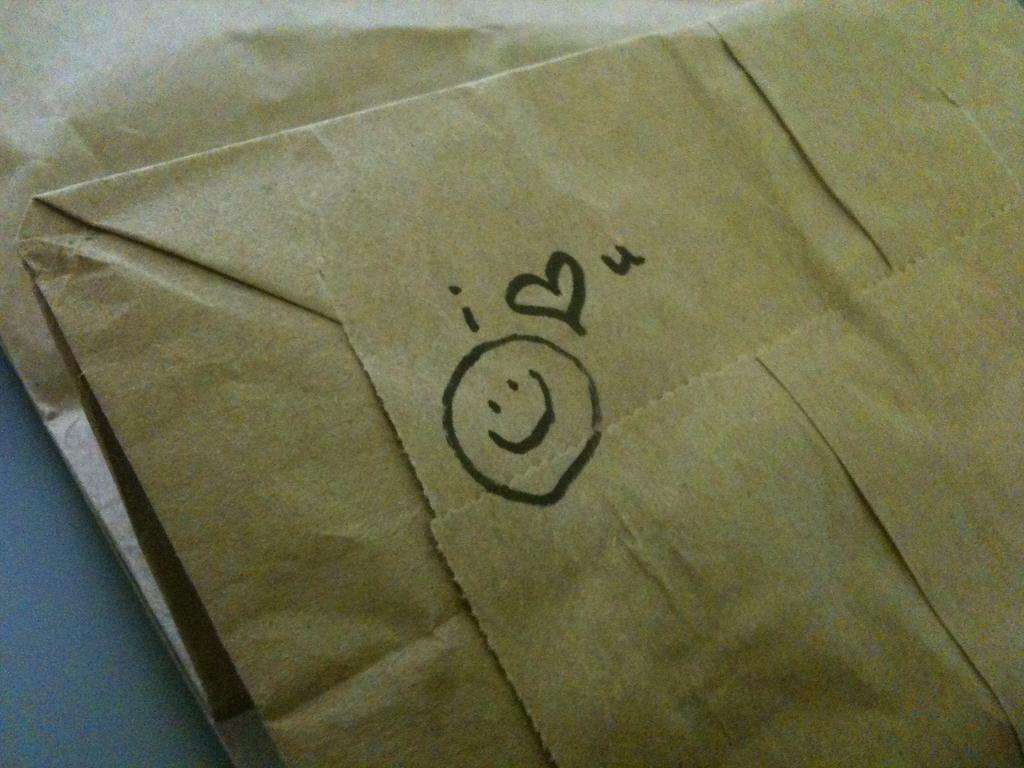<image>
Create a compact narrative representing the image presented. Paper bag with a smiley face and i heart u on  it in black marker 